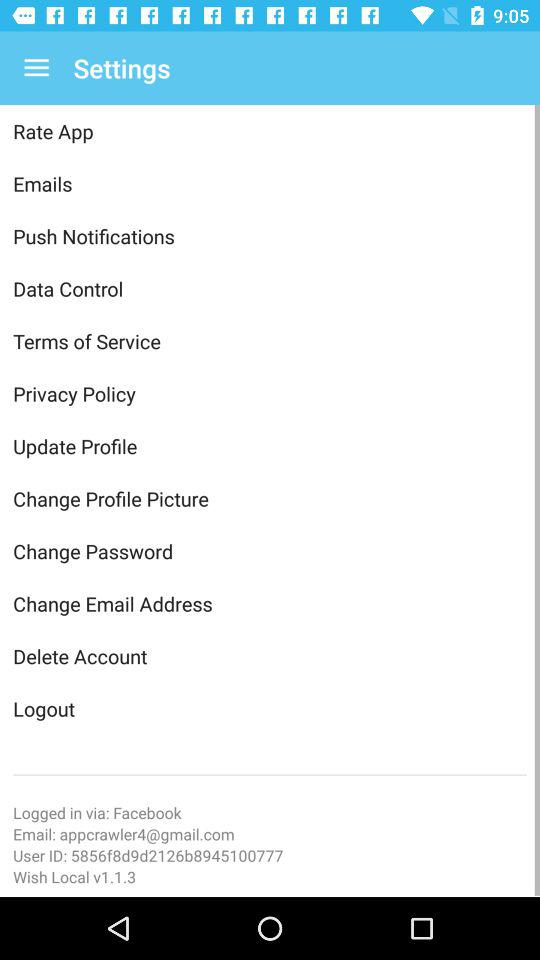What is the given email address? The email address is appcrawler4@gmail.com. 